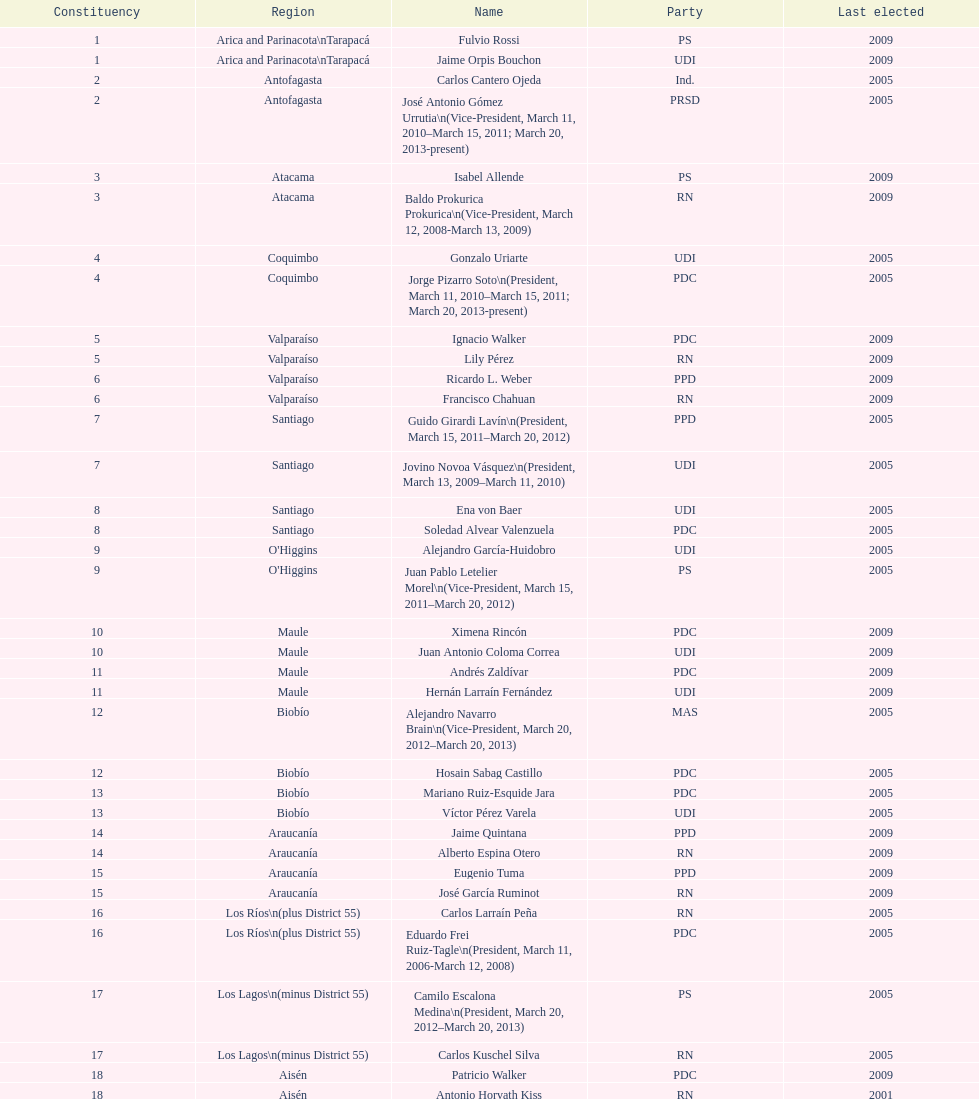In the table, how many constituencies are there in total? 19. 